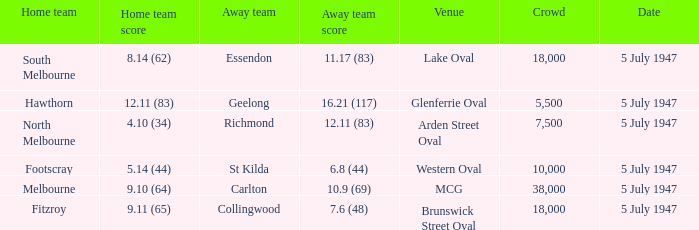What home team played an away team with a score of 6.8 (44)? Footscray. 